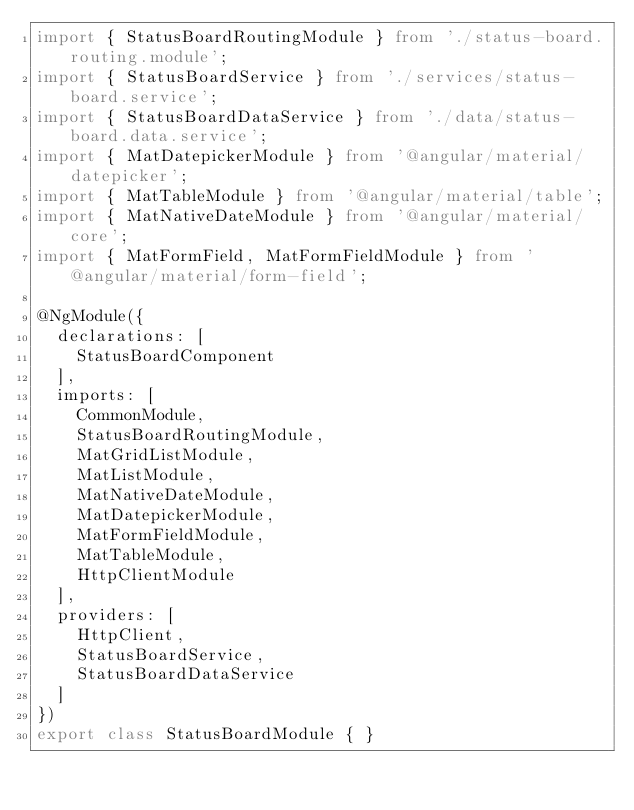Convert code to text. <code><loc_0><loc_0><loc_500><loc_500><_TypeScript_>import { StatusBoardRoutingModule } from './status-board.routing.module';
import { StatusBoardService } from './services/status-board.service';
import { StatusBoardDataService } from './data/status-board.data.service';
import { MatDatepickerModule } from '@angular/material/datepicker';
import { MatTableModule } from '@angular/material/table';
import { MatNativeDateModule } from '@angular/material/core';
import { MatFormField, MatFormFieldModule } from '@angular/material/form-field';

@NgModule({
  declarations: [
    StatusBoardComponent
  ],
  imports: [  
    CommonModule,
    StatusBoardRoutingModule,
    MatGridListModule,
    MatListModule,
    MatNativeDateModule,
    MatDatepickerModule,
    MatFormFieldModule,
    MatTableModule,
    HttpClientModule
  ],
  providers: [
    HttpClient,
    StatusBoardService,
    StatusBoardDataService
  ]
})
export class StatusBoardModule { }
</code> 